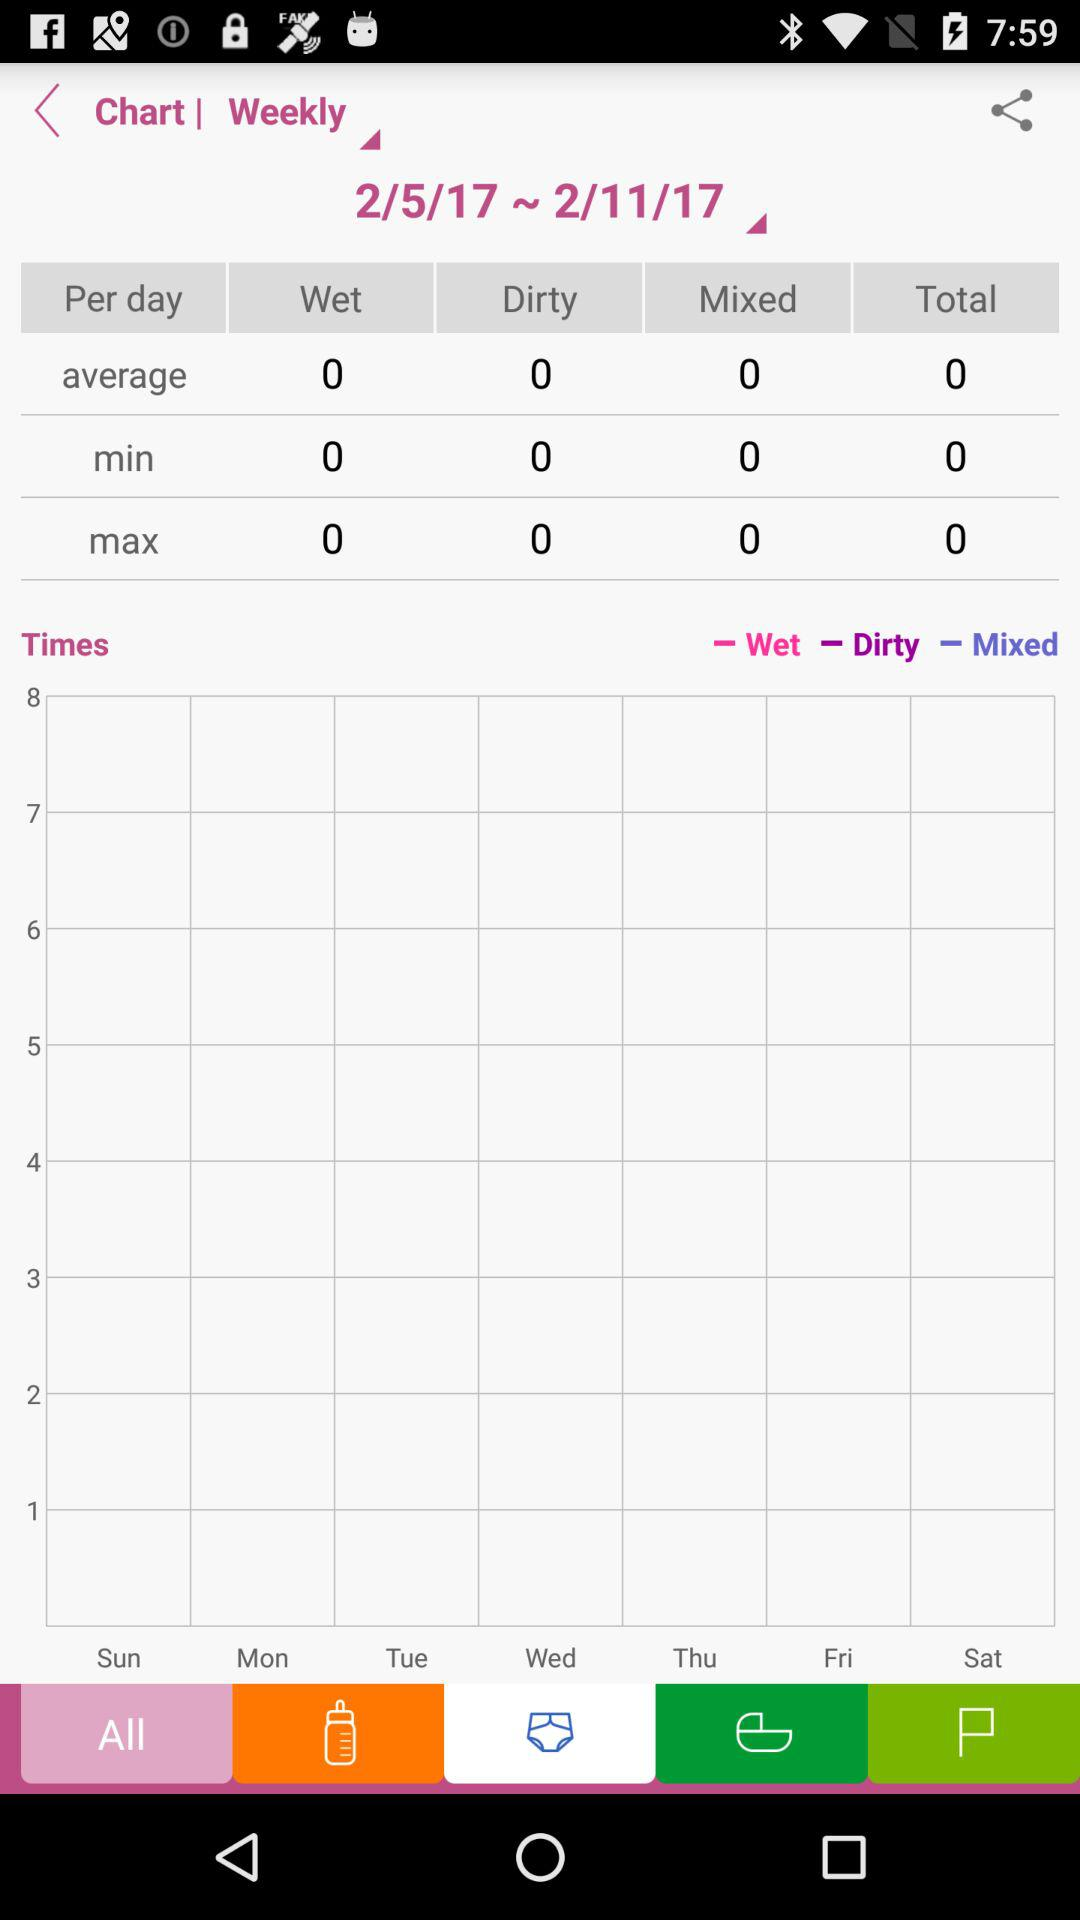What is the average number of diapers used per day?
Answer the question using a single word or phrase. 0 